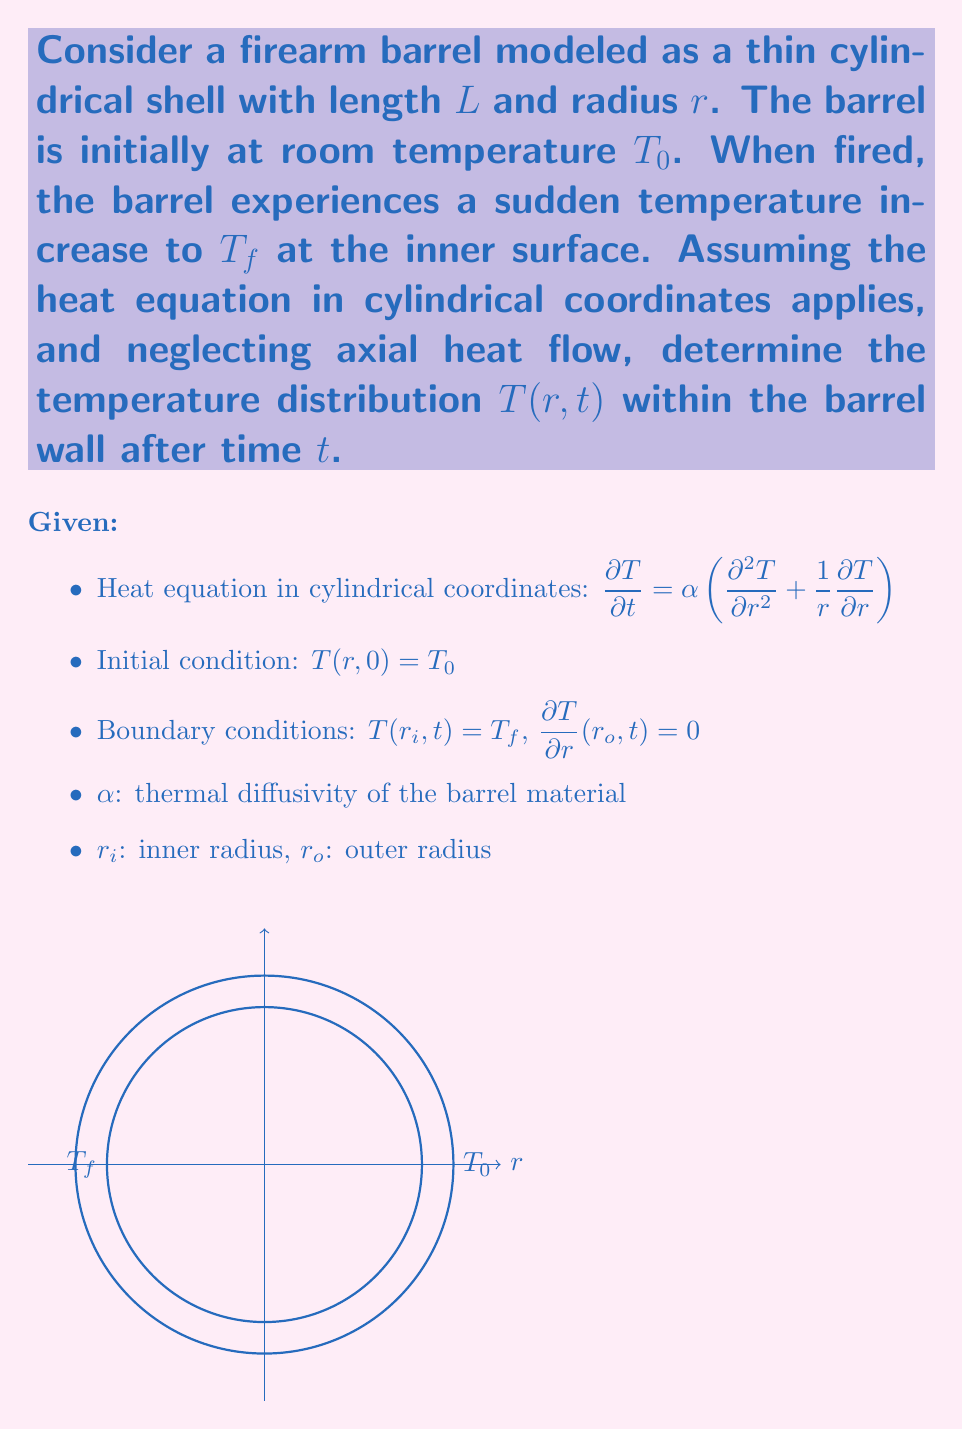Help me with this question. To solve this problem, we'll use the separation of variables method:

1) Assume a solution of the form $T(r,t) = R(r)G(t)$

2) Substitute into the heat equation:
   $$\frac{R(r)G'(t)}{\alpha G(t)} = R''(r) + \frac{1}{r}R'(r)$$

3) Separate variables:
   $$\frac{G'(t)}{\alpha G(t)} = \frac{R''(r) + \frac{1}{r}R'(r)}{R(r)} = -\lambda^2$$

4) Solve the time equation:
   $G(t) = Ce^{-\alpha\lambda^2t}$

5) Solve the radial equation:
   $r^2R'' + rR' + \lambda^2r^2R = 0$
   This is Bessel's equation of order zero. The general solution is:
   $R(r) = AJ_0(\lambda r) + BY_0(\lambda r)$

6) Apply boundary conditions:
   At $r = r_i$: $T(r_i,t) = T_f$
   At $r = r_o$: $\frac{\partial T}{\partial r}(r_o,t) = 0$

7) The solution that satisfies these conditions is:
   $$T(r,t) = T_0 + (T_f - T_0)\sum_{n=1}^{\infty} \frac{2}{J_0(\lambda_n r_o)} \frac{J_0(\lambda_n r)}{J_0(\lambda_n r_i)} e^{-\alpha\lambda_n^2t}$$

   where $\lambda_n$ are the positive roots of:
   $J_0(\lambda r_i)Y_1(\lambda r_o) - J_1(\lambda r_o)Y_0(\lambda r_i) = 0$

8) As $t \to \infty$, the exponential terms decay, and the steady-state solution is reached:
   $$T(r,\infty) = T_0 + (T_f - T_0)\frac{\ln(r/r_o)}{\ln(r_i/r_o)}$$
Answer: $$T(r,t) = T_0 + (T_f - T_0)\sum_{n=1}^{\infty} \frac{2}{J_0(\lambda_n r_o)} \frac{J_0(\lambda_n r)}{J_0(\lambda_n r_i)} e^{-\alpha\lambda_n^2t}$$ 